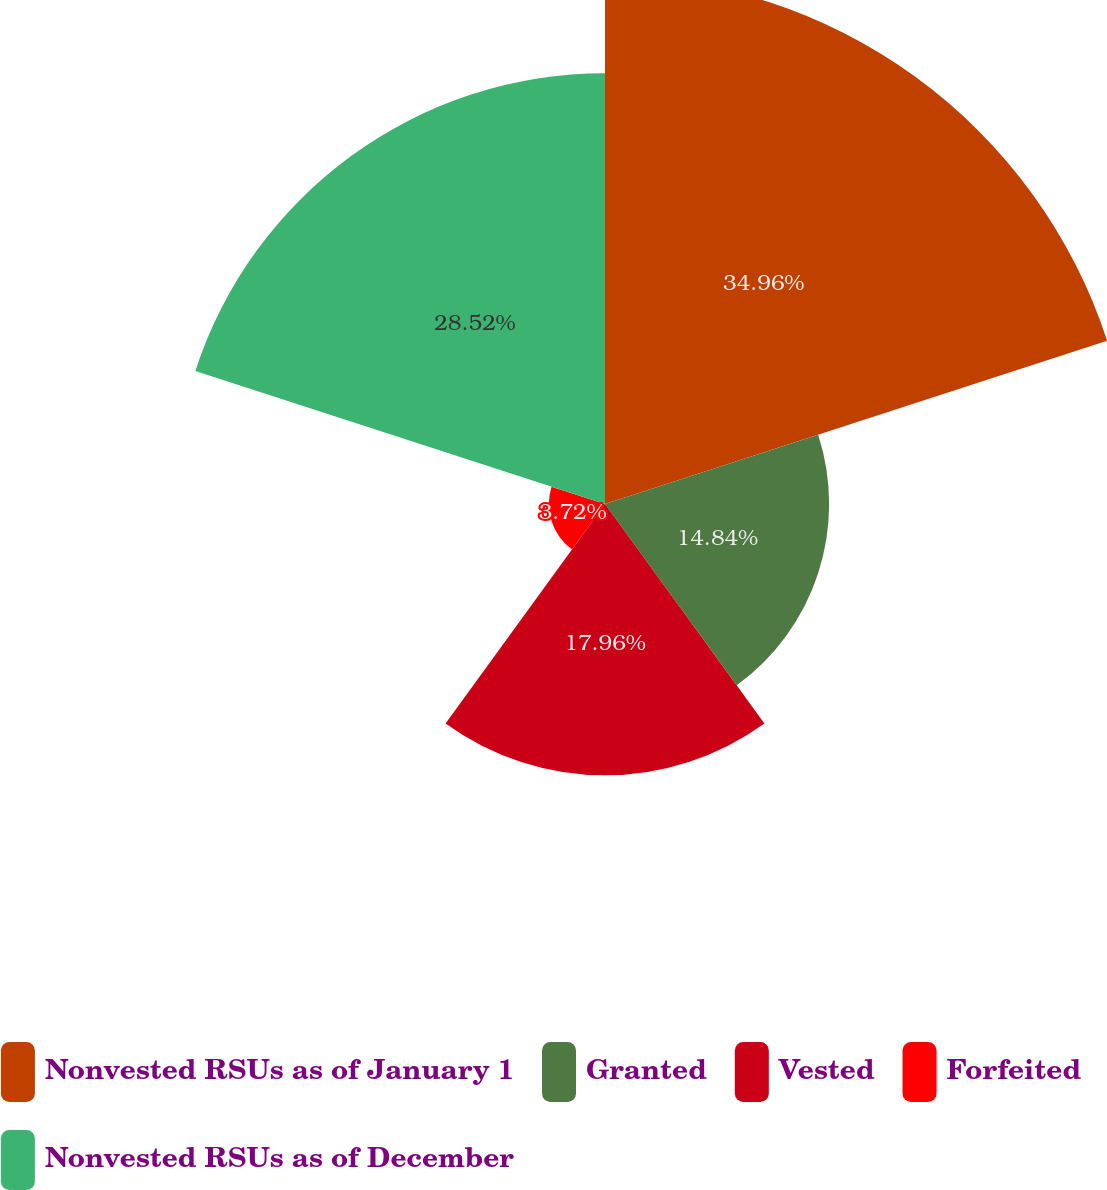<chart> <loc_0><loc_0><loc_500><loc_500><pie_chart><fcel>Nonvested RSUs as of January 1<fcel>Granted<fcel>Vested<fcel>Forfeited<fcel>Nonvested RSUs as of December<nl><fcel>34.96%<fcel>14.84%<fcel>17.96%<fcel>3.72%<fcel>28.52%<nl></chart> 